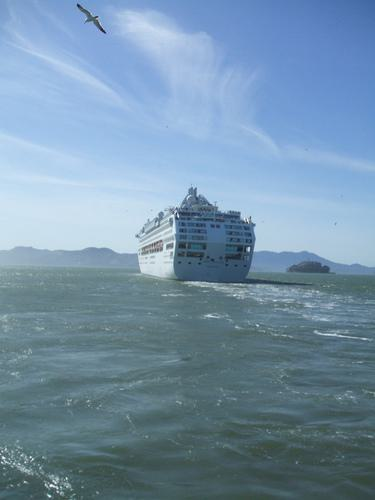What kind of ship is shown in the image? The ship in the image is a cruise ship. Its multi-deck structure and large size are characteristic of passenger ships designed for leisure voyages, where guests enjoy various onboard amenities and entertainment. 